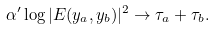Convert formula to latex. <formula><loc_0><loc_0><loc_500><loc_500>\alpha ^ { \prime } \log | E ( y _ { a } , y _ { b } ) | ^ { 2 } \rightarrow \tau _ { a } + \tau _ { b } .</formula> 